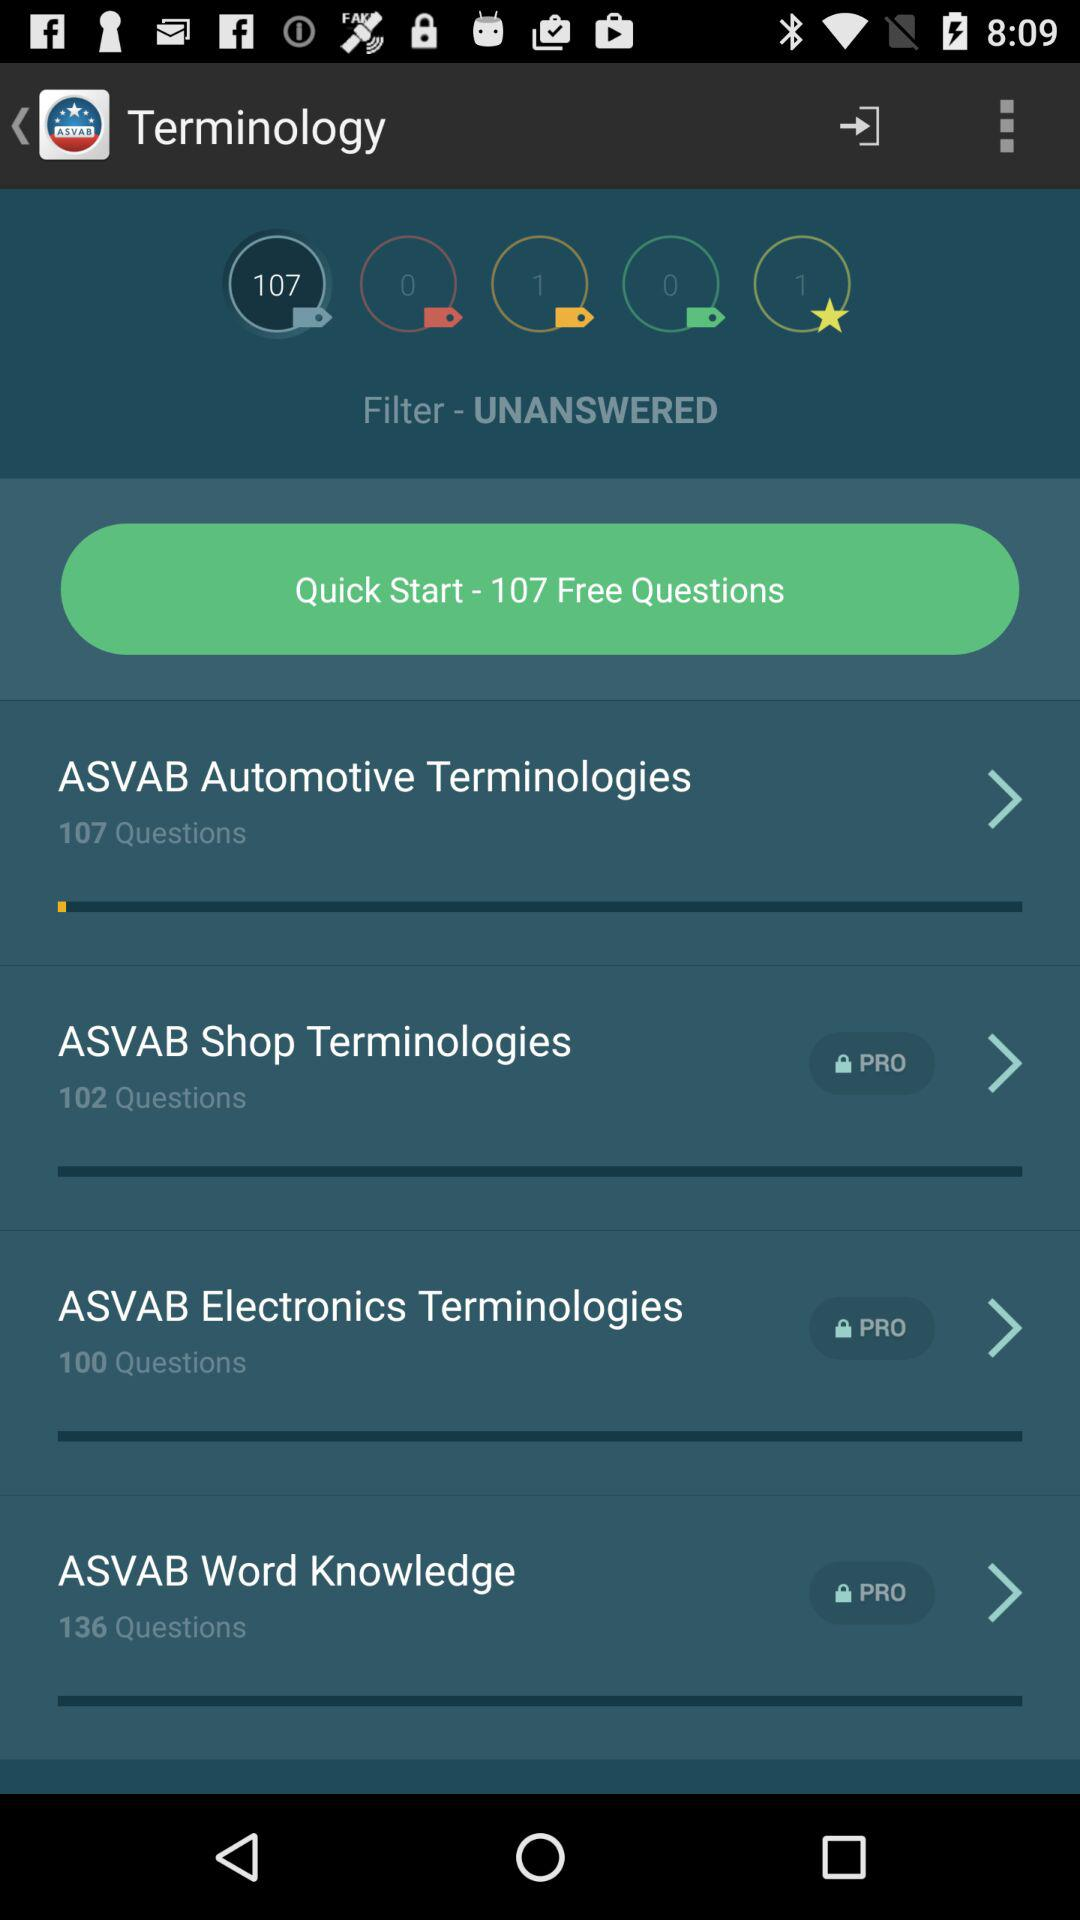How many questions are there in "ASVAB Word Knowledge"? There are 136 questions in "ASVAB Word Knowledge". 